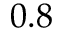Convert formula to latex. <formula><loc_0><loc_0><loc_500><loc_500>0 . 8</formula> 